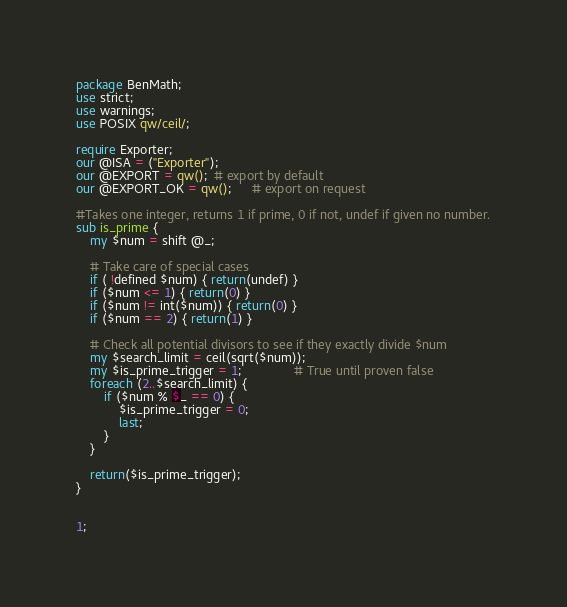Convert code to text. <code><loc_0><loc_0><loc_500><loc_500><_Perl_>package BenMath;
use strict;
use warnings;
use POSIX qw/ceil/;

require Exporter;
our @ISA = ("Exporter");
our @EXPORT = qw();  # export by default
our @EXPORT_OK = qw();      # export on request

#Takes one integer, returns 1 if prime, 0 if not, undef if given no number.
sub is_prime {
    my $num = shift @_;
    
    # Take care of special cases
    if ( !defined $num) { return(undef) }
    if ($num <= 1) { return(0) }
    if ($num != int($num)) { return(0) }
    if ($num == 2) { return(1) }
    
    # Check all potential divisors to see if they exactly divide $num
    my $search_limit = ceil(sqrt($num));
    my $is_prime_trigger = 1;               # True until proven false
    foreach (2..$search_limit) {
        if ($num % $_ == 0) {
            $is_prime_trigger = 0;
            last;
        }
    }
    
    return($is_prime_trigger);
}


1;</code> 